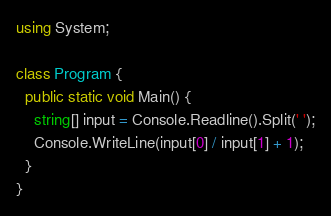Convert code to text. <code><loc_0><loc_0><loc_500><loc_500><_C#_>using System;

class Program {
  public static void Main() {
    string[] input = Console.Readline().Split(' ');
    Console.WriteLine(input[0] / input[1] + 1);
  }
}</code> 